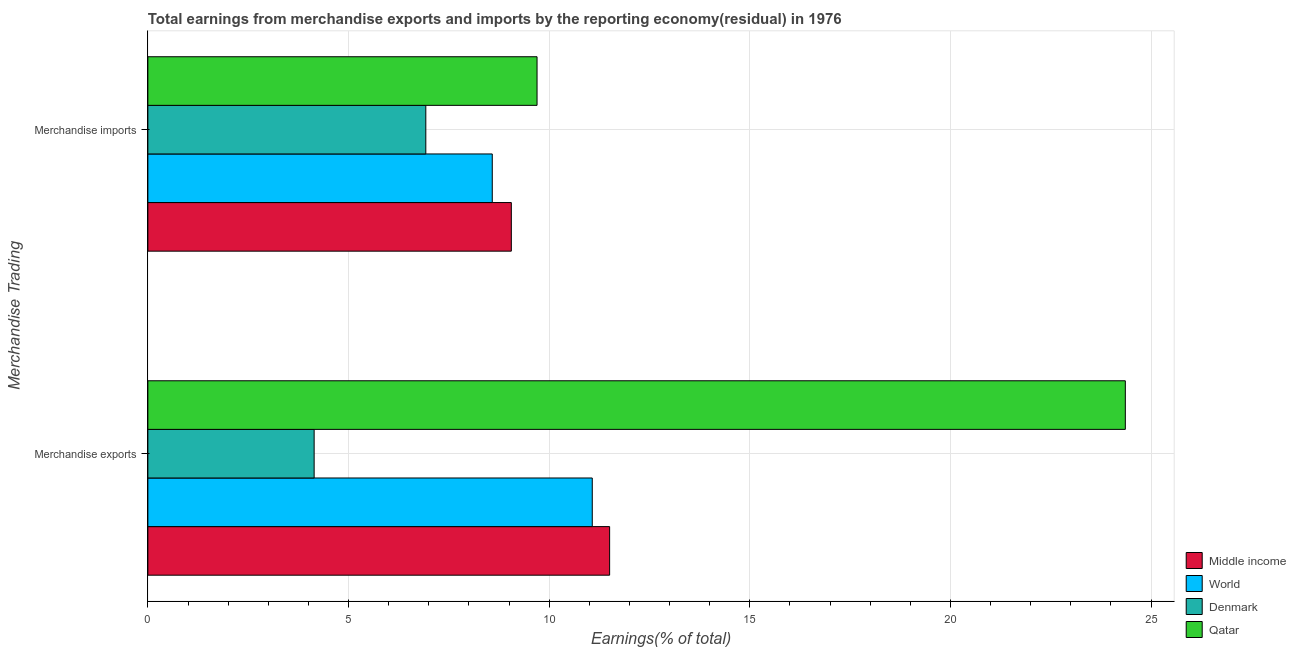Are the number of bars per tick equal to the number of legend labels?
Ensure brevity in your answer.  Yes. Are the number of bars on each tick of the Y-axis equal?
Ensure brevity in your answer.  Yes. How many bars are there on the 1st tick from the top?
Provide a succinct answer. 4. What is the label of the 2nd group of bars from the top?
Your answer should be compact. Merchandise exports. What is the earnings from merchandise exports in Middle income?
Give a very brief answer. 11.51. Across all countries, what is the maximum earnings from merchandise imports?
Provide a succinct answer. 9.7. Across all countries, what is the minimum earnings from merchandise exports?
Offer a very short reply. 4.14. In which country was the earnings from merchandise exports maximum?
Your answer should be compact. Qatar. In which country was the earnings from merchandise exports minimum?
Your response must be concise. Denmark. What is the total earnings from merchandise exports in the graph?
Keep it short and to the point. 51.08. What is the difference between the earnings from merchandise imports in Qatar and that in Middle income?
Your answer should be compact. 0.64. What is the difference between the earnings from merchandise imports in World and the earnings from merchandise exports in Qatar?
Ensure brevity in your answer.  -15.78. What is the average earnings from merchandise exports per country?
Offer a very short reply. 12.77. What is the difference between the earnings from merchandise imports and earnings from merchandise exports in Middle income?
Provide a succinct answer. -2.45. In how many countries, is the earnings from merchandise imports greater than 4 %?
Offer a terse response. 4. What is the ratio of the earnings from merchandise imports in Middle income to that in Qatar?
Provide a succinct answer. 0.93. Is the earnings from merchandise exports in Denmark less than that in Qatar?
Provide a short and direct response. Yes. In how many countries, is the earnings from merchandise exports greater than the average earnings from merchandise exports taken over all countries?
Your answer should be compact. 1. What does the 4th bar from the bottom in Merchandise exports represents?
Keep it short and to the point. Qatar. How many bars are there?
Keep it short and to the point. 8. Are all the bars in the graph horizontal?
Give a very brief answer. Yes. How many legend labels are there?
Make the answer very short. 4. What is the title of the graph?
Your answer should be compact. Total earnings from merchandise exports and imports by the reporting economy(residual) in 1976. Does "Cote d'Ivoire" appear as one of the legend labels in the graph?
Ensure brevity in your answer.  No. What is the label or title of the X-axis?
Ensure brevity in your answer.  Earnings(% of total). What is the label or title of the Y-axis?
Your response must be concise. Merchandise Trading. What is the Earnings(% of total) of Middle income in Merchandise exports?
Provide a succinct answer. 11.51. What is the Earnings(% of total) of World in Merchandise exports?
Your answer should be very brief. 11.07. What is the Earnings(% of total) in Denmark in Merchandise exports?
Keep it short and to the point. 4.14. What is the Earnings(% of total) of Qatar in Merchandise exports?
Your answer should be very brief. 24.36. What is the Earnings(% of total) of Middle income in Merchandise imports?
Offer a very short reply. 9.06. What is the Earnings(% of total) of World in Merchandise imports?
Give a very brief answer. 8.58. What is the Earnings(% of total) of Denmark in Merchandise imports?
Offer a terse response. 6.93. What is the Earnings(% of total) in Qatar in Merchandise imports?
Your response must be concise. 9.7. Across all Merchandise Trading, what is the maximum Earnings(% of total) of Middle income?
Keep it short and to the point. 11.51. Across all Merchandise Trading, what is the maximum Earnings(% of total) in World?
Keep it short and to the point. 11.07. Across all Merchandise Trading, what is the maximum Earnings(% of total) in Denmark?
Give a very brief answer. 6.93. Across all Merchandise Trading, what is the maximum Earnings(% of total) in Qatar?
Make the answer very short. 24.36. Across all Merchandise Trading, what is the minimum Earnings(% of total) of Middle income?
Your answer should be compact. 9.06. Across all Merchandise Trading, what is the minimum Earnings(% of total) in World?
Your answer should be very brief. 8.58. Across all Merchandise Trading, what is the minimum Earnings(% of total) in Denmark?
Provide a short and direct response. 4.14. Across all Merchandise Trading, what is the minimum Earnings(% of total) of Qatar?
Keep it short and to the point. 9.7. What is the total Earnings(% of total) in Middle income in the graph?
Make the answer very short. 20.56. What is the total Earnings(% of total) of World in the graph?
Your answer should be very brief. 19.66. What is the total Earnings(% of total) in Denmark in the graph?
Provide a succinct answer. 11.07. What is the total Earnings(% of total) in Qatar in the graph?
Keep it short and to the point. 34.06. What is the difference between the Earnings(% of total) in Middle income in Merchandise exports and that in Merchandise imports?
Provide a short and direct response. 2.45. What is the difference between the Earnings(% of total) of World in Merchandise exports and that in Merchandise imports?
Your answer should be very brief. 2.49. What is the difference between the Earnings(% of total) in Denmark in Merchandise exports and that in Merchandise imports?
Provide a succinct answer. -2.78. What is the difference between the Earnings(% of total) of Qatar in Merchandise exports and that in Merchandise imports?
Ensure brevity in your answer.  14.66. What is the difference between the Earnings(% of total) in Middle income in Merchandise exports and the Earnings(% of total) in World in Merchandise imports?
Provide a short and direct response. 2.92. What is the difference between the Earnings(% of total) in Middle income in Merchandise exports and the Earnings(% of total) in Denmark in Merchandise imports?
Give a very brief answer. 4.58. What is the difference between the Earnings(% of total) of Middle income in Merchandise exports and the Earnings(% of total) of Qatar in Merchandise imports?
Your response must be concise. 1.81. What is the difference between the Earnings(% of total) of World in Merchandise exports and the Earnings(% of total) of Denmark in Merchandise imports?
Your answer should be compact. 4.15. What is the difference between the Earnings(% of total) of World in Merchandise exports and the Earnings(% of total) of Qatar in Merchandise imports?
Your answer should be very brief. 1.38. What is the difference between the Earnings(% of total) in Denmark in Merchandise exports and the Earnings(% of total) in Qatar in Merchandise imports?
Make the answer very short. -5.55. What is the average Earnings(% of total) of Middle income per Merchandise Trading?
Provide a short and direct response. 10.28. What is the average Earnings(% of total) of World per Merchandise Trading?
Your answer should be compact. 9.83. What is the average Earnings(% of total) in Denmark per Merchandise Trading?
Your answer should be very brief. 5.53. What is the average Earnings(% of total) in Qatar per Merchandise Trading?
Your answer should be very brief. 17.03. What is the difference between the Earnings(% of total) in Middle income and Earnings(% of total) in World in Merchandise exports?
Provide a succinct answer. 0.43. What is the difference between the Earnings(% of total) of Middle income and Earnings(% of total) of Denmark in Merchandise exports?
Make the answer very short. 7.36. What is the difference between the Earnings(% of total) in Middle income and Earnings(% of total) in Qatar in Merchandise exports?
Keep it short and to the point. -12.85. What is the difference between the Earnings(% of total) in World and Earnings(% of total) in Denmark in Merchandise exports?
Provide a succinct answer. 6.93. What is the difference between the Earnings(% of total) in World and Earnings(% of total) in Qatar in Merchandise exports?
Ensure brevity in your answer.  -13.28. What is the difference between the Earnings(% of total) of Denmark and Earnings(% of total) of Qatar in Merchandise exports?
Your response must be concise. -20.21. What is the difference between the Earnings(% of total) in Middle income and Earnings(% of total) in World in Merchandise imports?
Your answer should be very brief. 0.47. What is the difference between the Earnings(% of total) in Middle income and Earnings(% of total) in Denmark in Merchandise imports?
Ensure brevity in your answer.  2.13. What is the difference between the Earnings(% of total) of Middle income and Earnings(% of total) of Qatar in Merchandise imports?
Ensure brevity in your answer.  -0.64. What is the difference between the Earnings(% of total) of World and Earnings(% of total) of Denmark in Merchandise imports?
Give a very brief answer. 1.66. What is the difference between the Earnings(% of total) of World and Earnings(% of total) of Qatar in Merchandise imports?
Ensure brevity in your answer.  -1.12. What is the difference between the Earnings(% of total) in Denmark and Earnings(% of total) in Qatar in Merchandise imports?
Offer a terse response. -2.77. What is the ratio of the Earnings(% of total) in Middle income in Merchandise exports to that in Merchandise imports?
Your response must be concise. 1.27. What is the ratio of the Earnings(% of total) of World in Merchandise exports to that in Merchandise imports?
Ensure brevity in your answer.  1.29. What is the ratio of the Earnings(% of total) in Denmark in Merchandise exports to that in Merchandise imports?
Your answer should be very brief. 0.6. What is the ratio of the Earnings(% of total) of Qatar in Merchandise exports to that in Merchandise imports?
Ensure brevity in your answer.  2.51. What is the difference between the highest and the second highest Earnings(% of total) in Middle income?
Provide a short and direct response. 2.45. What is the difference between the highest and the second highest Earnings(% of total) in World?
Make the answer very short. 2.49. What is the difference between the highest and the second highest Earnings(% of total) in Denmark?
Your answer should be compact. 2.78. What is the difference between the highest and the second highest Earnings(% of total) of Qatar?
Give a very brief answer. 14.66. What is the difference between the highest and the lowest Earnings(% of total) in Middle income?
Give a very brief answer. 2.45. What is the difference between the highest and the lowest Earnings(% of total) in World?
Provide a succinct answer. 2.49. What is the difference between the highest and the lowest Earnings(% of total) in Denmark?
Your answer should be compact. 2.78. What is the difference between the highest and the lowest Earnings(% of total) in Qatar?
Provide a succinct answer. 14.66. 